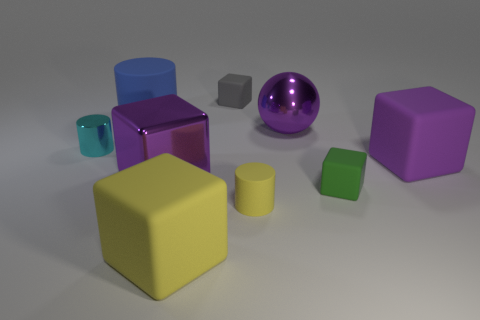Can you describe the lighting in the scene and how it might affect the colors we see? The lighting in the scene is soft and diffused, which allows the colors of the objects to appear true to their hues with minimal harsh shadows. This lighting condition helps in discerning the colors properly but may slightly wash out the intensity of the colors. 